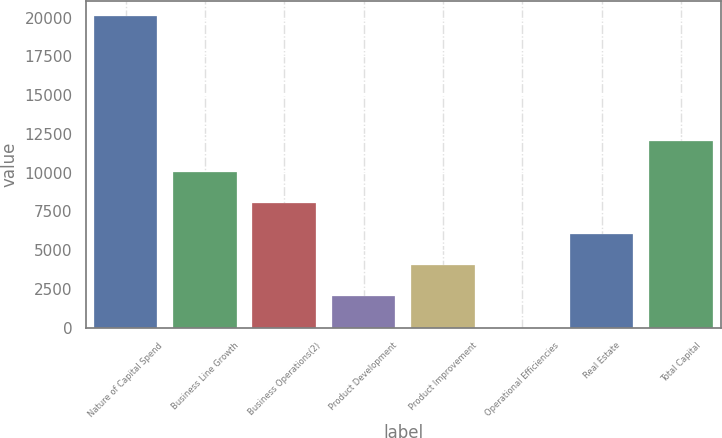Convert chart to OTSL. <chart><loc_0><loc_0><loc_500><loc_500><bar_chart><fcel>Nature of Capital Spend<fcel>Business Line Growth<fcel>Business Operations(2)<fcel>Product Development<fcel>Product Improvement<fcel>Operational Efficiencies<fcel>Real Estate<fcel>Total Capital<nl><fcel>20093<fcel>10051<fcel>8042.6<fcel>2017.4<fcel>4025.8<fcel>9<fcel>6034.2<fcel>12059.4<nl></chart> 